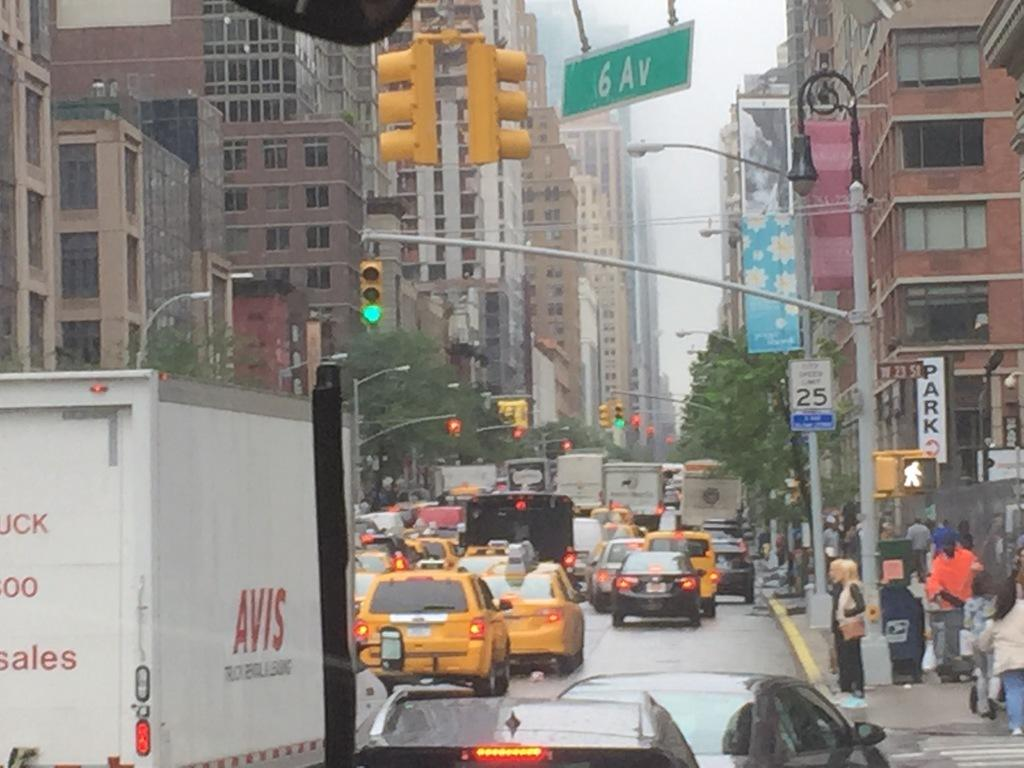<image>
Create a compact narrative representing the image presented. On a crowded street a cargo van has AVIS written on the side of it. 